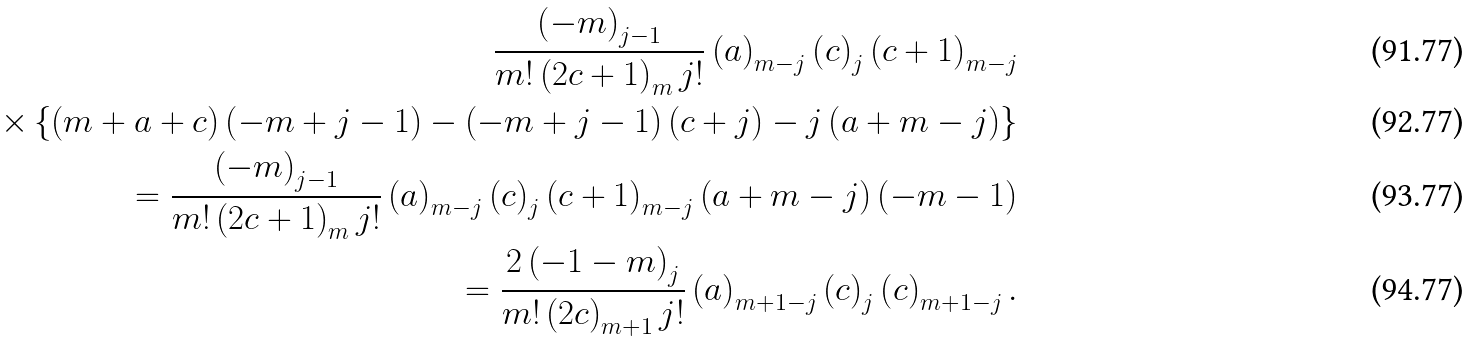Convert formula to latex. <formula><loc_0><loc_0><loc_500><loc_500>\frac { \left ( - m \right ) _ { j - 1 } } { m ! \left ( 2 c + 1 \right ) _ { m } j ! } \left ( a \right ) _ { m - j } \left ( c \right ) _ { j } \left ( c + 1 \right ) _ { m - j } \\ \times \left \{ \left ( m + a + c \right ) \left ( - m + j - 1 \right ) - \left ( - m + j - 1 \right ) \left ( c + j \right ) - j \left ( a + m - j \right ) \right \} \\ = \frac { \left ( - m \right ) _ { j - 1 } } { m ! \left ( 2 c + 1 \right ) _ { m } j ! } \left ( a \right ) _ { m - j } \left ( c \right ) _ { j } \left ( c + 1 \right ) _ { m - j } \left ( a + m - j \right ) \left ( - m - 1 \right ) \\ = \frac { 2 \left ( - 1 - m \right ) _ { j } } { m ! \left ( 2 c \right ) _ { m + 1 } j ! } \left ( a \right ) _ { m + 1 - j } \left ( c \right ) _ { j } \left ( c \right ) _ { m + 1 - j } .</formula> 